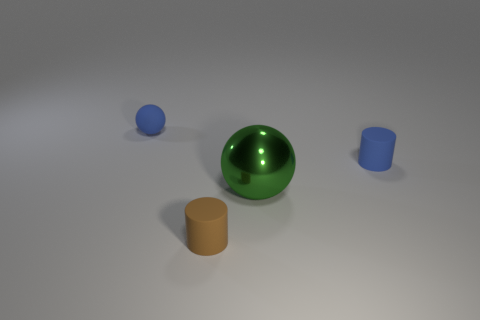Add 1 green metal things. How many objects exist? 5 Subtract 0 yellow cubes. How many objects are left? 4 Subtract all large red objects. Subtract all spheres. How many objects are left? 2 Add 3 blue cylinders. How many blue cylinders are left? 4 Add 3 metal things. How many metal things exist? 4 